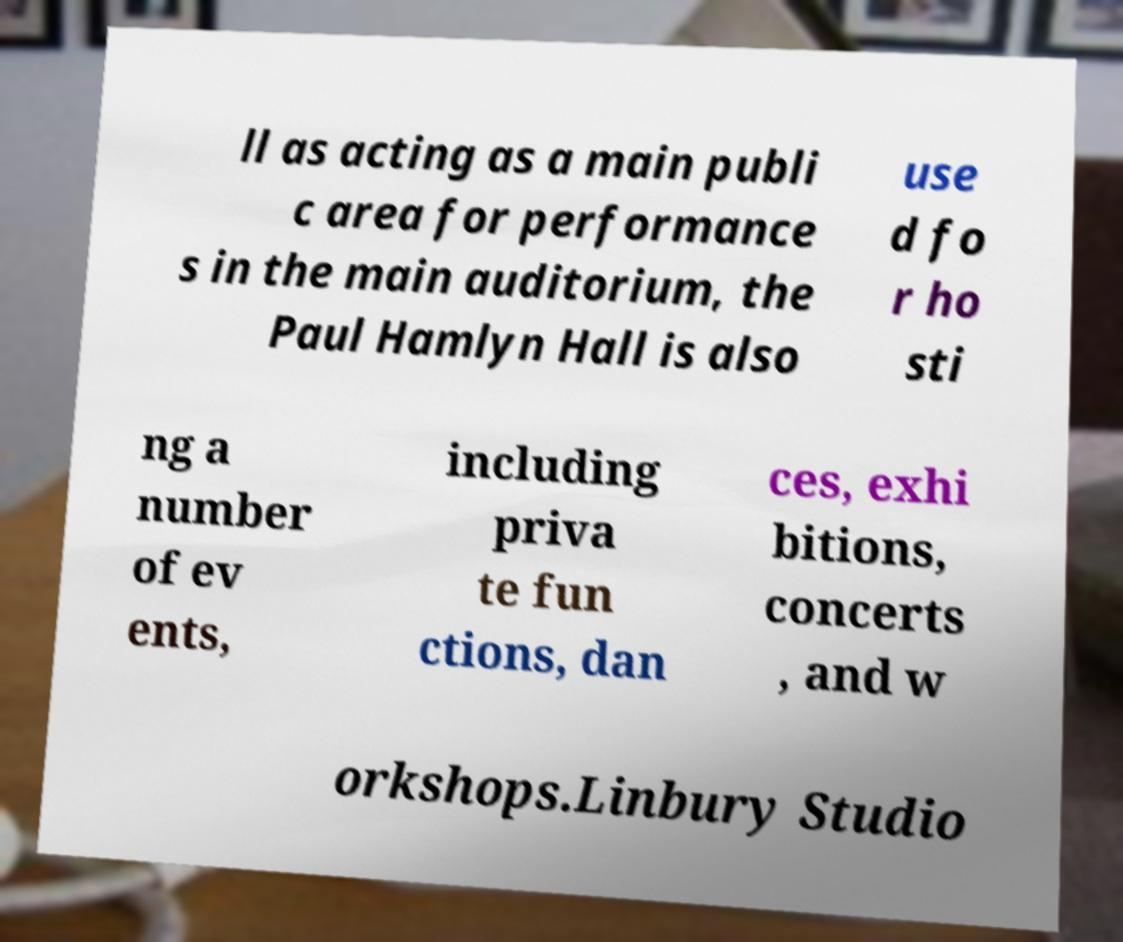Can you read and provide the text displayed in the image?This photo seems to have some interesting text. Can you extract and type it out for me? ll as acting as a main publi c area for performance s in the main auditorium, the Paul Hamlyn Hall is also use d fo r ho sti ng a number of ev ents, including priva te fun ctions, dan ces, exhi bitions, concerts , and w orkshops.Linbury Studio 